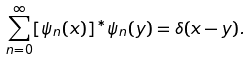<formula> <loc_0><loc_0><loc_500><loc_500>\sum _ { n = 0 } ^ { \infty } [ \psi _ { n } ( x ) ] ^ { * } \psi _ { n } ( y ) = \delta ( x - y ) .</formula> 